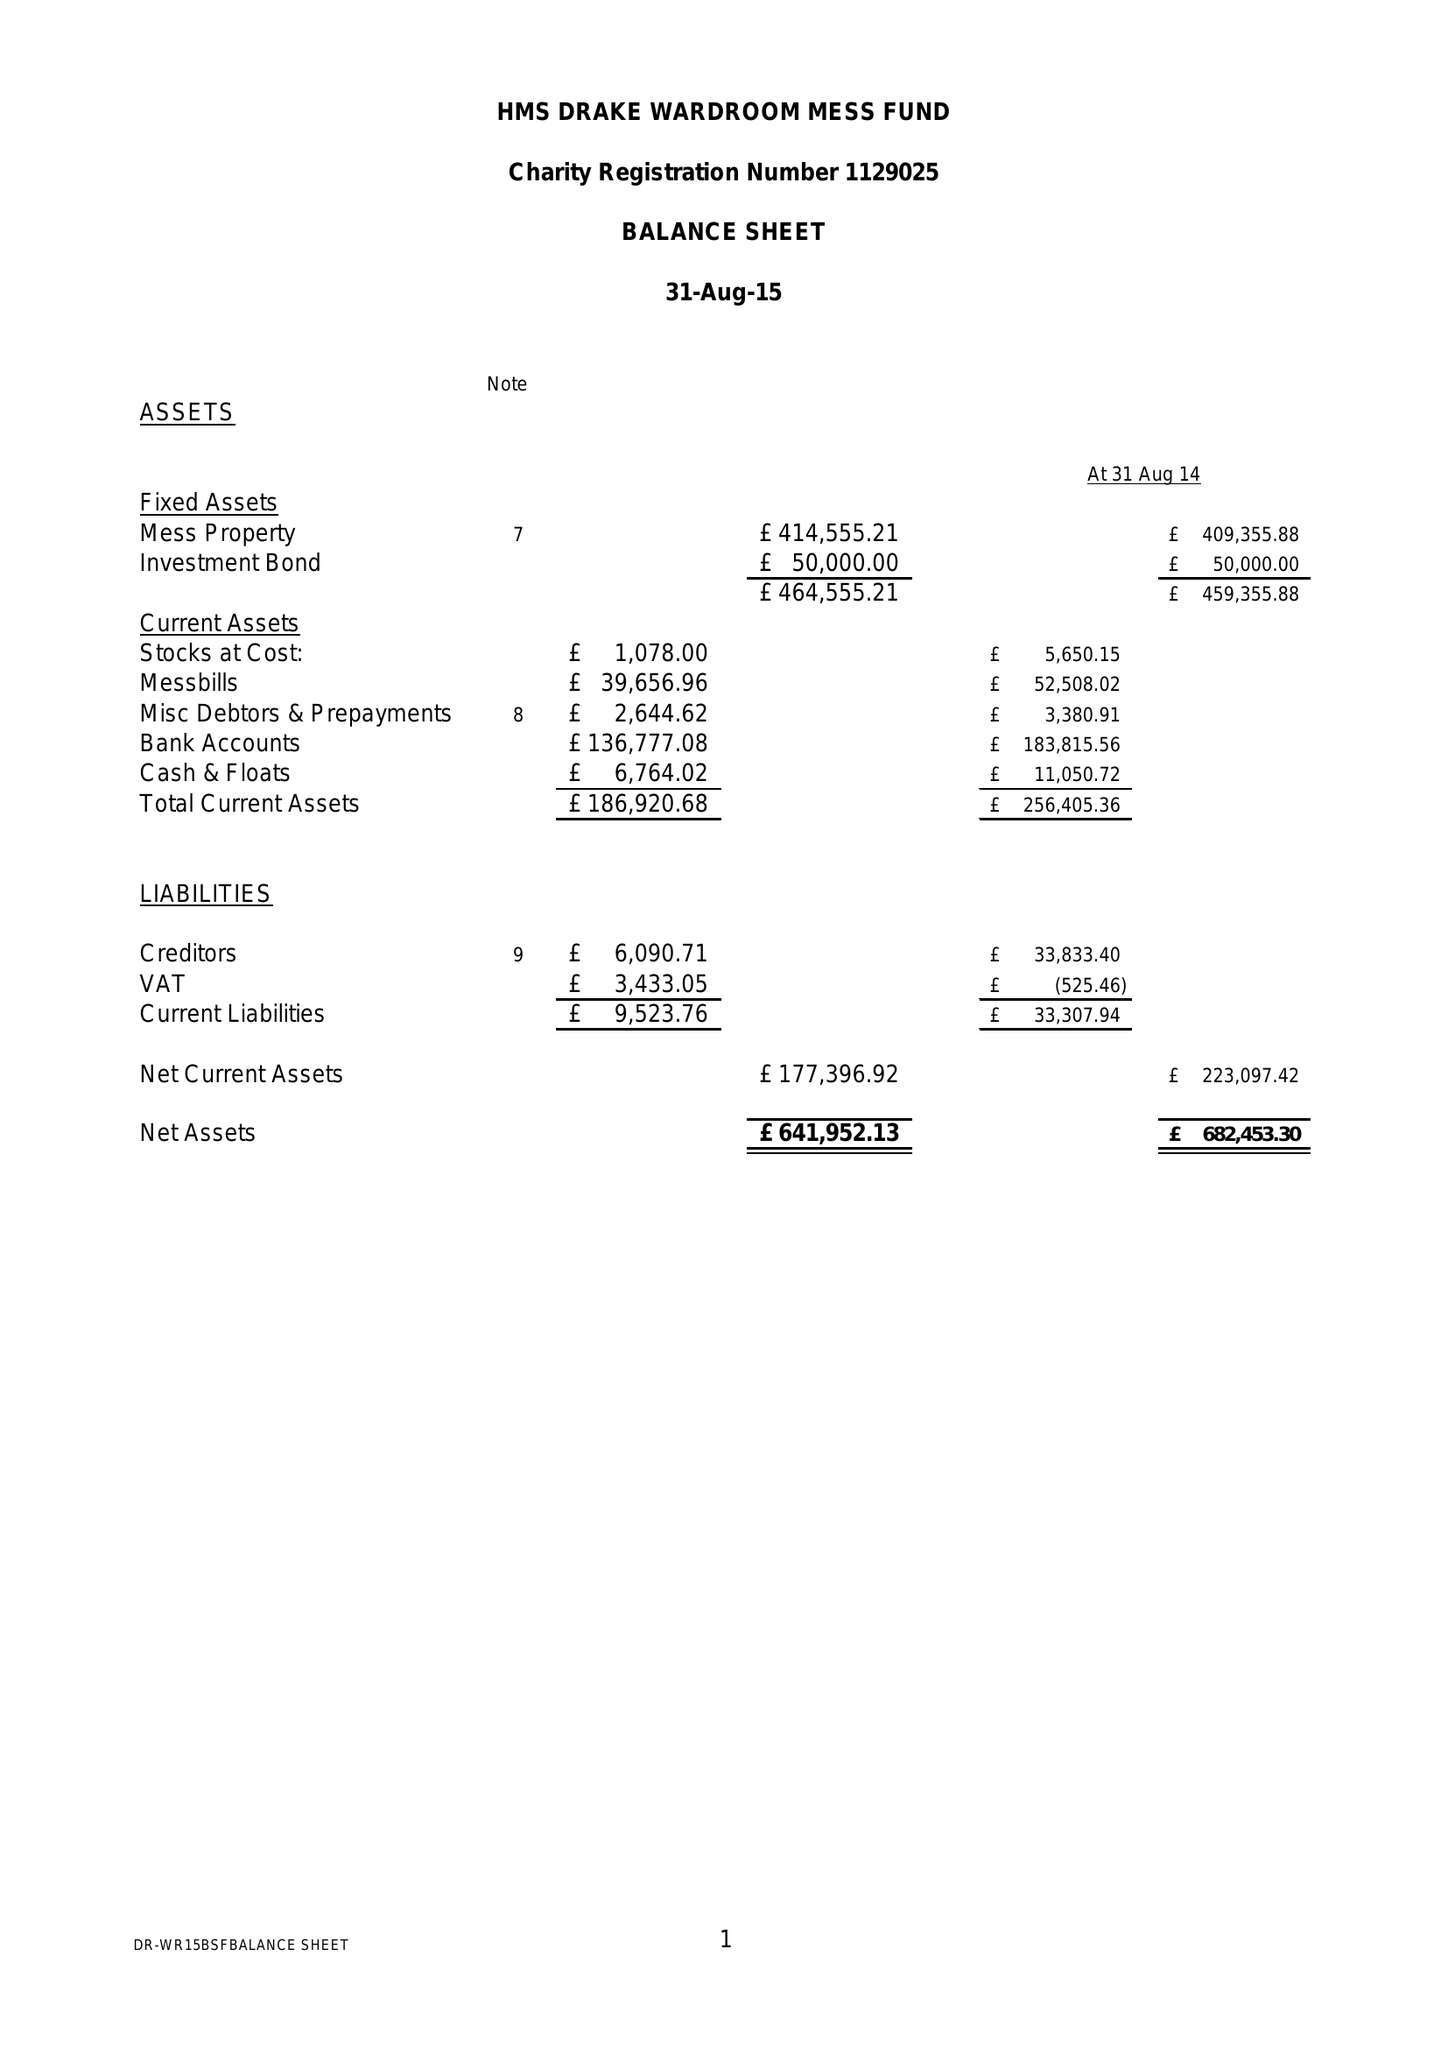What is the value for the address__street_line?
Answer the question using a single word or phrase. None 